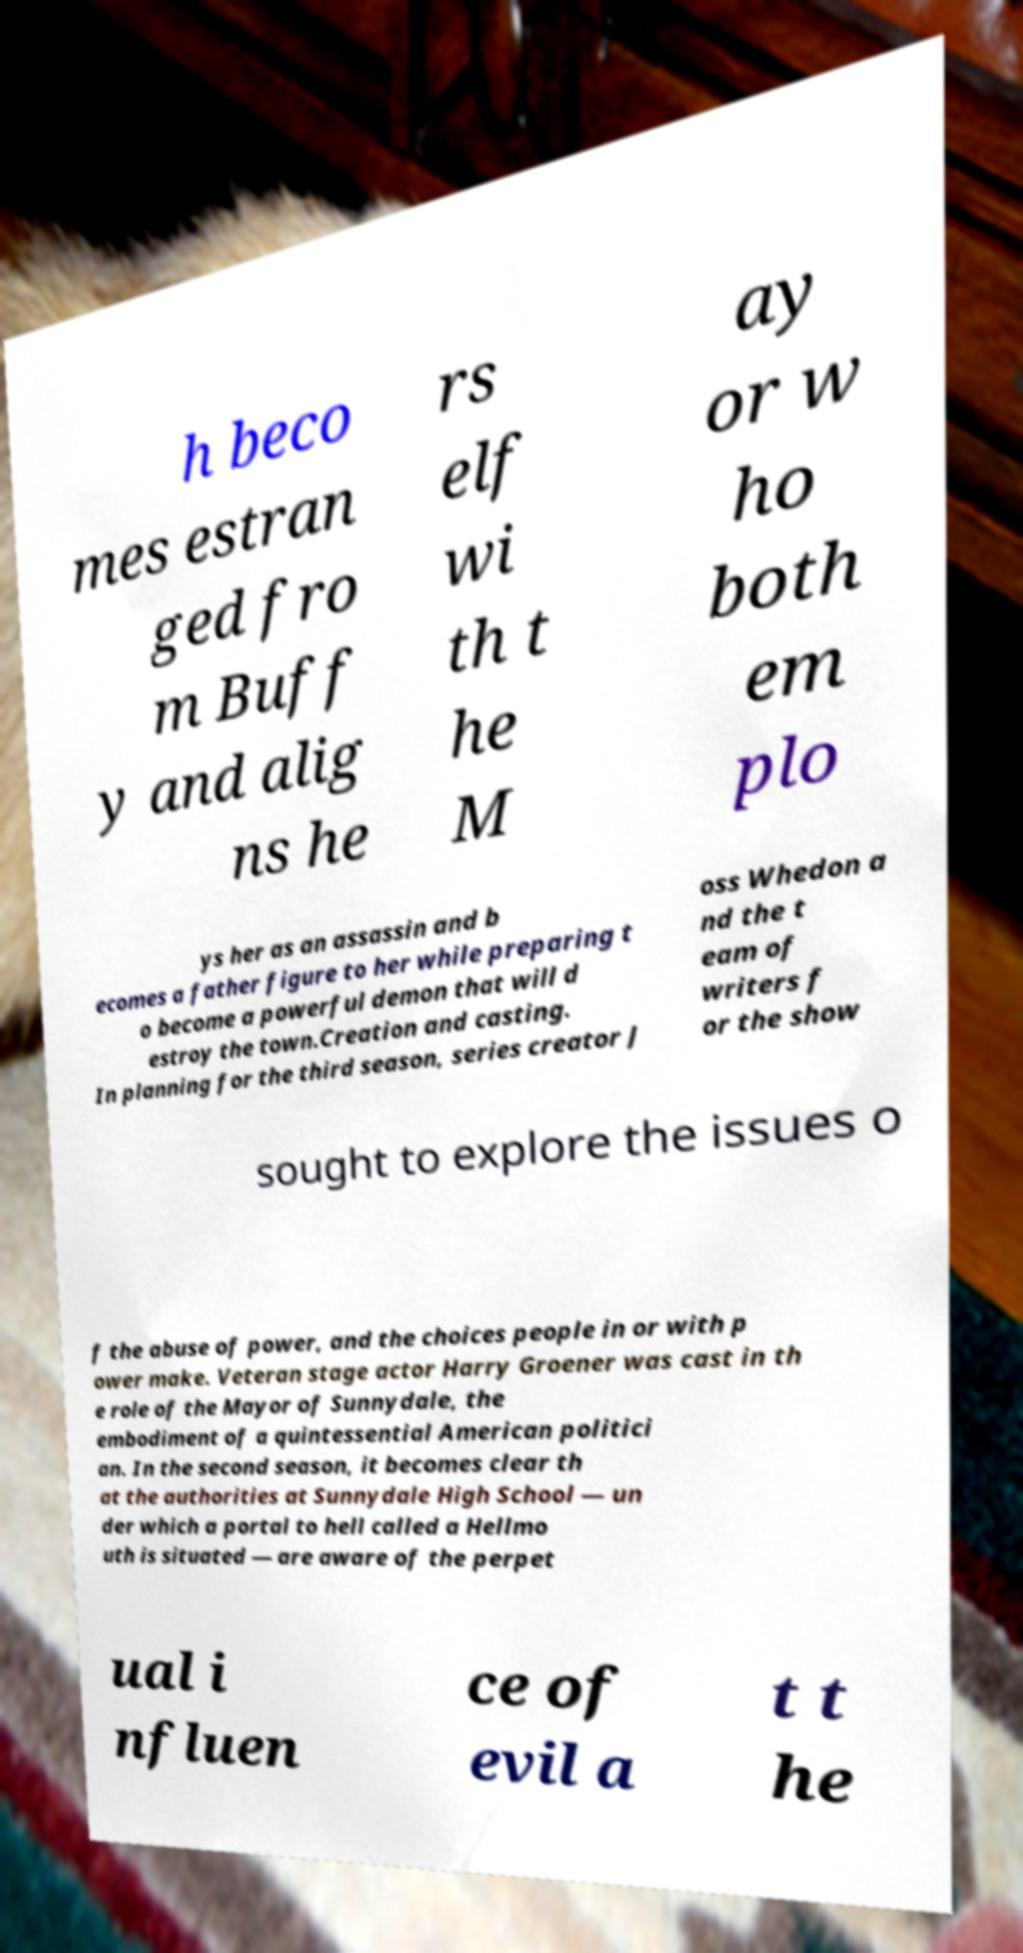Could you extract and type out the text from this image? h beco mes estran ged fro m Buff y and alig ns he rs elf wi th t he M ay or w ho both em plo ys her as an assassin and b ecomes a father figure to her while preparing t o become a powerful demon that will d estroy the town.Creation and casting. In planning for the third season, series creator J oss Whedon a nd the t eam of writers f or the show sought to explore the issues o f the abuse of power, and the choices people in or with p ower make. Veteran stage actor Harry Groener was cast in th e role of the Mayor of Sunnydale, the embodiment of a quintessential American politici an. In the second season, it becomes clear th at the authorities at Sunnydale High School — un der which a portal to hell called a Hellmo uth is situated — are aware of the perpet ual i nfluen ce of evil a t t he 